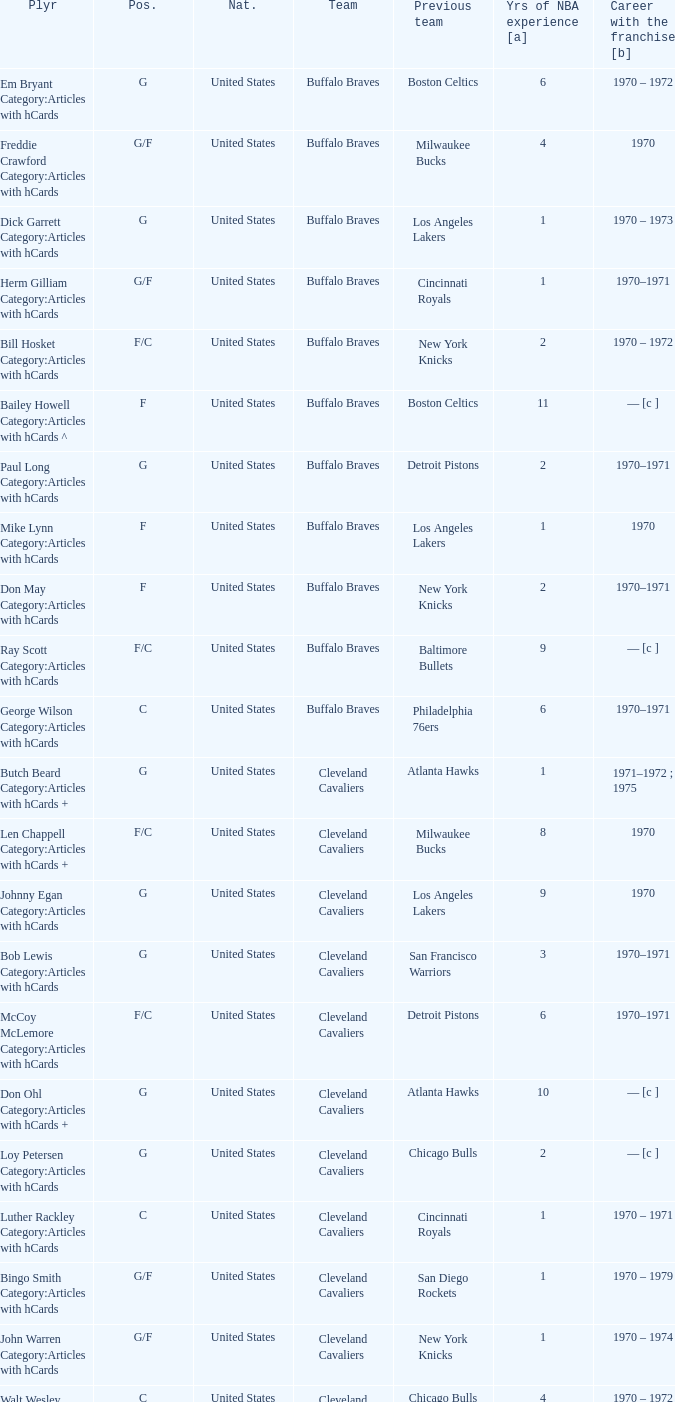Who is the player from the Buffalo Braves with the previous team Los Angeles Lakers and a career with the franchase in 1970? Mike Lynn Category:Articles with hCards. 